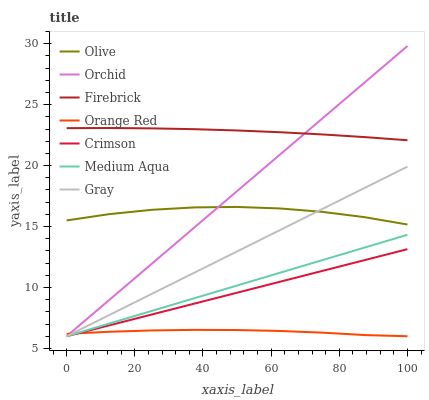Does Orange Red have the minimum area under the curve?
Answer yes or no. Yes. Does Firebrick have the maximum area under the curve?
Answer yes or no. Yes. Does Crimson have the minimum area under the curve?
Answer yes or no. No. Does Crimson have the maximum area under the curve?
Answer yes or no. No. Is Crimson the smoothest?
Answer yes or no. Yes. Is Olive the roughest?
Answer yes or no. Yes. Is Firebrick the smoothest?
Answer yes or no. No. Is Firebrick the roughest?
Answer yes or no. No. Does Gray have the lowest value?
Answer yes or no. Yes. Does Firebrick have the lowest value?
Answer yes or no. No. Does Orchid have the highest value?
Answer yes or no. Yes. Does Firebrick have the highest value?
Answer yes or no. No. Is Gray less than Firebrick?
Answer yes or no. Yes. Is Olive greater than Medium Aqua?
Answer yes or no. Yes. Does Orchid intersect Firebrick?
Answer yes or no. Yes. Is Orchid less than Firebrick?
Answer yes or no. No. Is Orchid greater than Firebrick?
Answer yes or no. No. Does Gray intersect Firebrick?
Answer yes or no. No. 